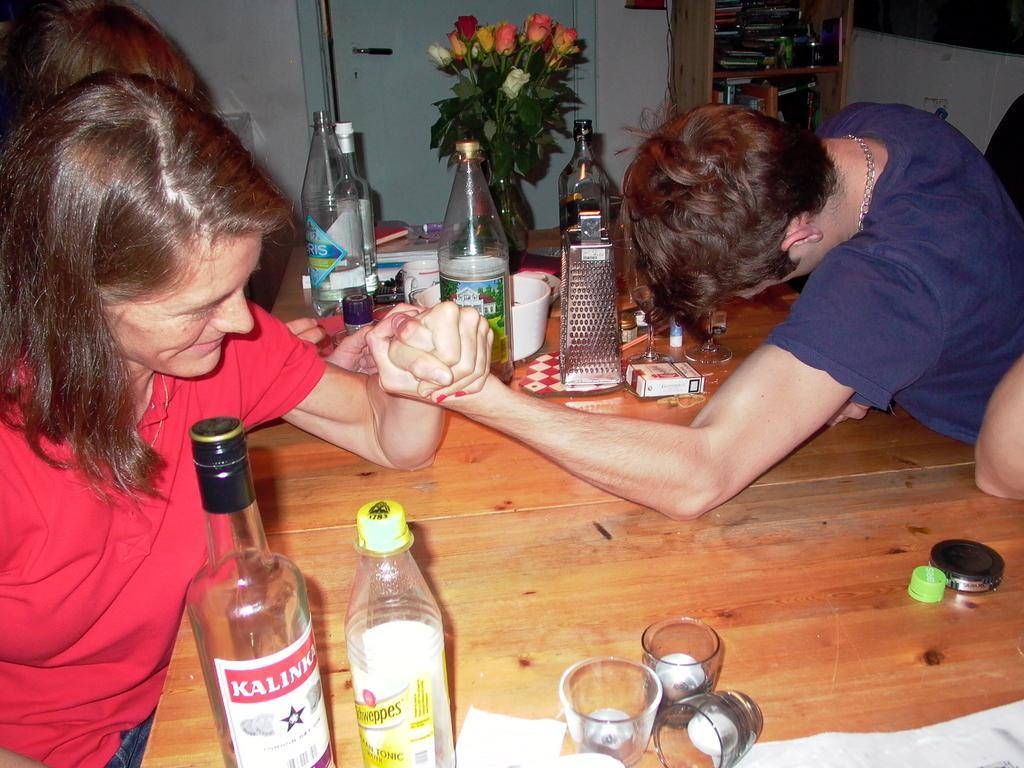Can you describe this image briefly? In this image i can see a woman and a man holding their hands. I can see a table on which there are few objects, bottles and a flower pot. In the background i can see a wall, a shelf and a door. 